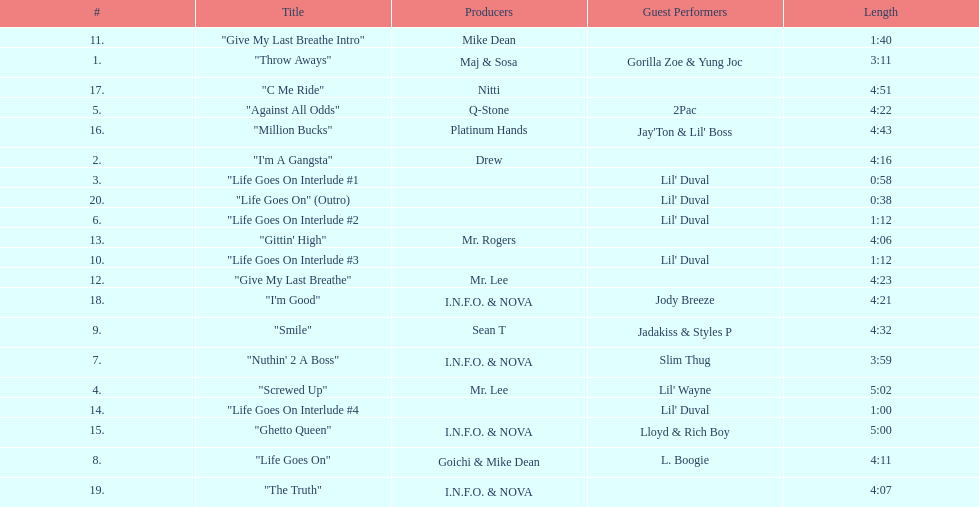What is the last track produced by mr. lee? "Give My Last Breathe". 